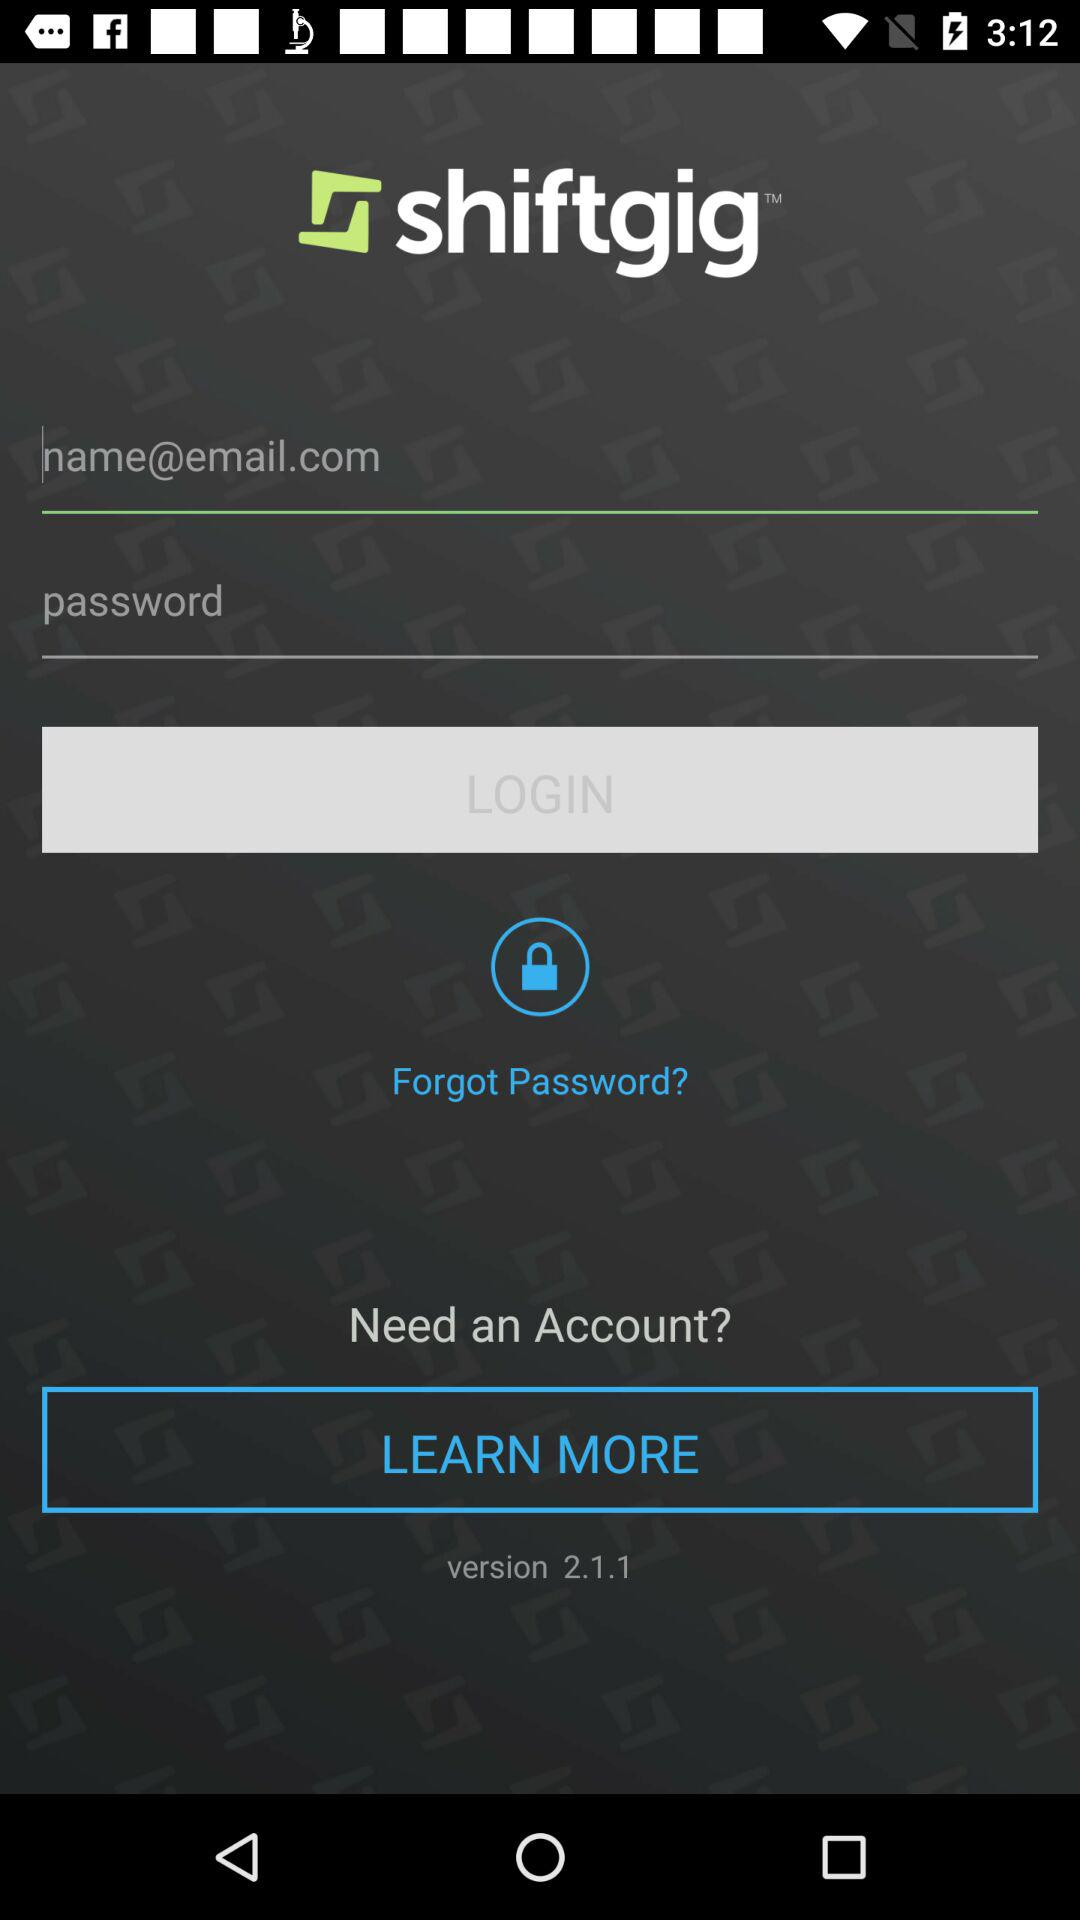What is the version?
Answer the question using a single word or phrase. The version is 2.1.1 